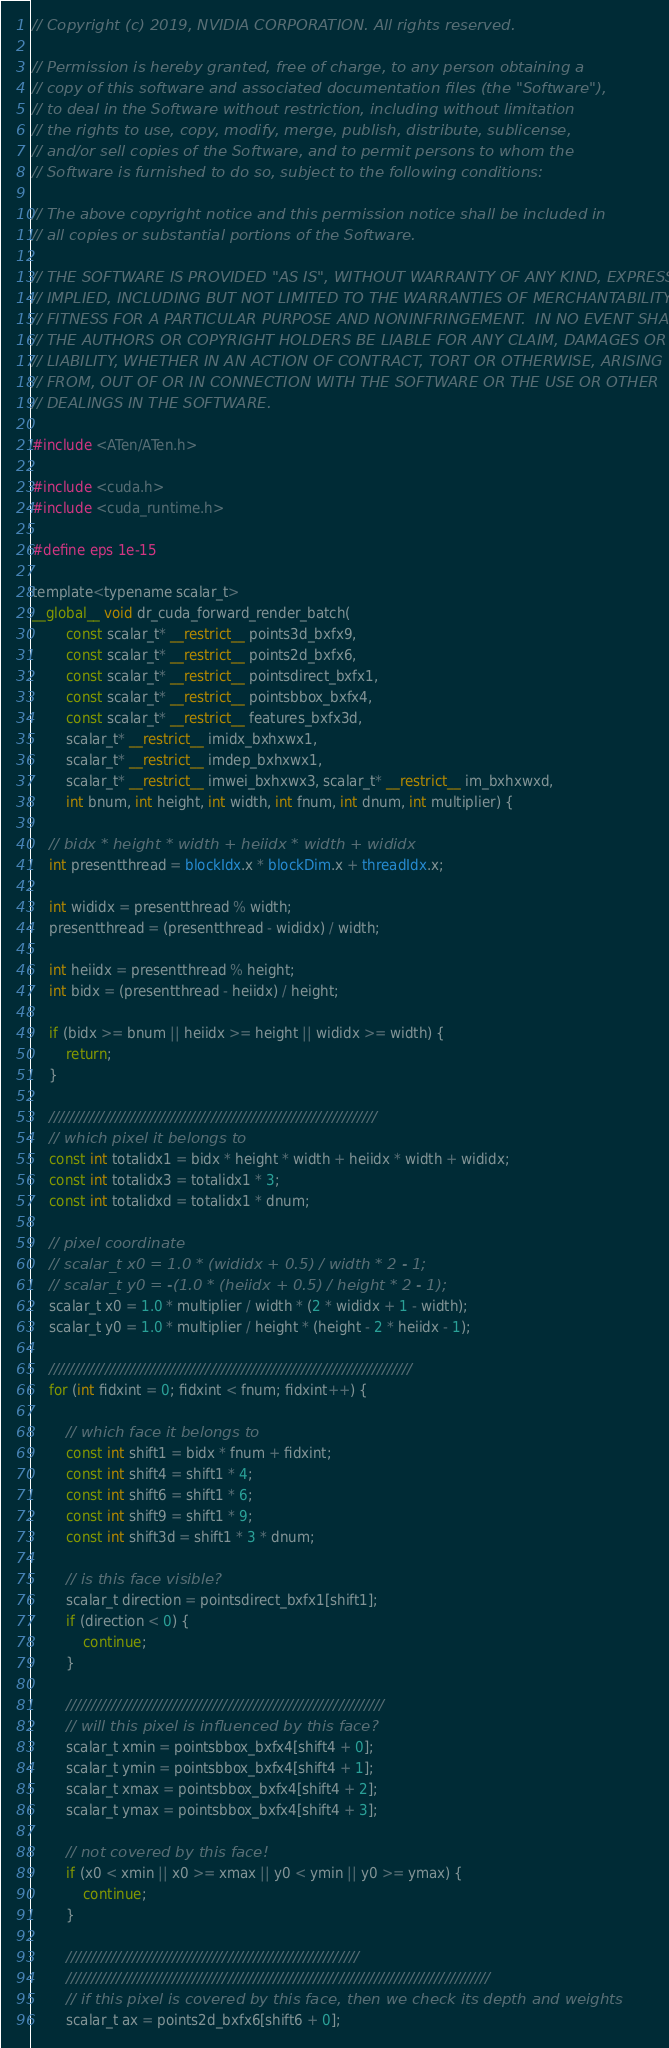<code> <loc_0><loc_0><loc_500><loc_500><_Cuda_>// Copyright (c) 2019, NVIDIA CORPORATION. All rights reserved.

// Permission is hereby granted, free of charge, to any person obtaining a
// copy of this software and associated documentation files (the "Software"),
// to deal in the Software without restriction, including without limitation
// the rights to use, copy, modify, merge, publish, distribute, sublicense,
// and/or sell copies of the Software, and to permit persons to whom the
// Software is furnished to do so, subject to the following conditions:

// The above copyright notice and this permission notice shall be included in
// all copies or substantial portions of the Software.

// THE SOFTWARE IS PROVIDED "AS IS", WITHOUT WARRANTY OF ANY KIND, EXPRESS OR
// IMPLIED, INCLUDING BUT NOT LIMITED TO THE WARRANTIES OF MERCHANTABILITY,
// FITNESS FOR A PARTICULAR PURPOSE AND NONINFRINGEMENT.  IN NO EVENT SHALL
// THE AUTHORS OR COPYRIGHT HOLDERS BE LIABLE FOR ANY CLAIM, DAMAGES OR OTHER
// LIABILITY, WHETHER IN AN ACTION OF CONTRACT, TORT OR OTHERWISE, ARISING
// FROM, OUT OF OR IN CONNECTION WITH THE SOFTWARE OR THE USE OR OTHER
// DEALINGS IN THE SOFTWARE.

#include <ATen/ATen.h>

#include <cuda.h>
#include <cuda_runtime.h>

#define eps 1e-15

template<typename scalar_t>
__global__ void dr_cuda_forward_render_batch(
		const scalar_t* __restrict__ points3d_bxfx9,
		const scalar_t* __restrict__ points2d_bxfx6,
		const scalar_t* __restrict__ pointsdirect_bxfx1,
		const scalar_t* __restrict__ pointsbbox_bxfx4,
		const scalar_t* __restrict__ features_bxfx3d,
		scalar_t* __restrict__ imidx_bxhxwx1,
		scalar_t* __restrict__ imdep_bxhxwx1,
		scalar_t* __restrict__ imwei_bxhxwx3, scalar_t* __restrict__ im_bxhxwxd,
		int bnum, int height, int width, int fnum, int dnum, int multiplier) {

	// bidx * height * width + heiidx * width + wididx
	int presentthread = blockIdx.x * blockDim.x + threadIdx.x;

	int wididx = presentthread % width;
	presentthread = (presentthread - wididx) / width;

	int heiidx = presentthread % height;
	int bidx = (presentthread - heiidx) / height;

	if (bidx >= bnum || heiidx >= height || wididx >= width) {
		return;
	}

	/////////////////////////////////////////////////////////////////
	// which pixel it belongs to
	const int totalidx1 = bidx * height * width + heiidx * width + wididx;
	const int totalidx3 = totalidx1 * 3;
	const int totalidxd = totalidx1 * dnum;

	// pixel coordinate
	// scalar_t x0 = 1.0 * (wididx + 0.5) / width * 2 - 1;
	// scalar_t y0 = -(1.0 * (heiidx + 0.5) / height * 2 - 1);
	scalar_t x0 = 1.0 * multiplier / width * (2 * wididx + 1 - width);
	scalar_t y0 = 1.0 * multiplier / height * (height - 2 * heiidx - 1);

	////////////////////////////////////////////////////////////////////////
	for (int fidxint = 0; fidxint < fnum; fidxint++) {

		// which face it belongs to
		const int shift1 = bidx * fnum + fidxint;
		const int shift4 = shift1 * 4;
		const int shift6 = shift1 * 6;
		const int shift9 = shift1 * 9;
		const int shift3d = shift1 * 3 * dnum;

		// is this face visible?
		scalar_t direction = pointsdirect_bxfx1[shift1];
		if (direction < 0) {
			continue;
		}

		///////////////////////////////////////////////////////////////
		// will this pixel is influenced by this face?
		scalar_t xmin = pointsbbox_bxfx4[shift4 + 0];
		scalar_t ymin = pointsbbox_bxfx4[shift4 + 1];
		scalar_t xmax = pointsbbox_bxfx4[shift4 + 2];
		scalar_t ymax = pointsbbox_bxfx4[shift4 + 3];

		// not covered by this face!
		if (x0 < xmin || x0 >= xmax || y0 < ymin || y0 >= ymax) {
			continue;
		}

		//////////////////////////////////////////////////////////
		////////////////////////////////////////////////////////////////////////////////////
		// if this pixel is covered by this face, then we check its depth and weights
		scalar_t ax = points2d_bxfx6[shift6 + 0];</code> 